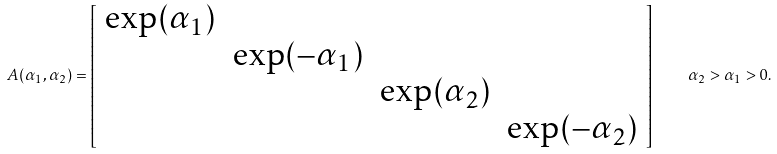<formula> <loc_0><loc_0><loc_500><loc_500>A ( \alpha _ { 1 } , \alpha _ { 2 } ) = \left [ \begin{array} { c c c c } \exp ( \alpha _ { 1 } ) & & & \\ & \exp ( - \alpha _ { 1 } ) & & \\ & & \exp ( \alpha _ { 2 } ) & \\ & & & \exp ( - \alpha _ { 2 } ) \end{array} \right ] \quad \alpha _ { 2 } > \alpha _ { 1 } > 0 .</formula> 